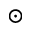Convert formula to latex. <formula><loc_0><loc_0><loc_500><loc_500>_ { \odot }</formula> 